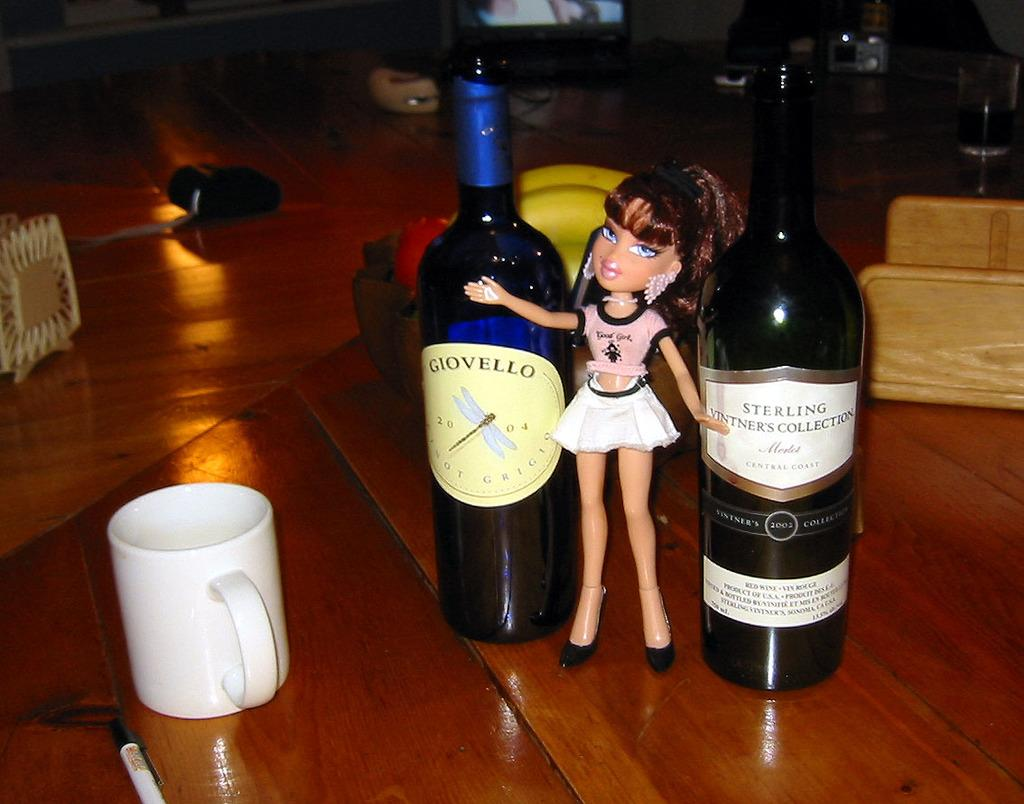What type of containers can be seen in the image? There are bottles and a cup in the image. What type of toy is present in the image? There is a toy doll in the image. What is the color of the surface on which the objects are placed? The surface is brown in color. Can you describe any other objects visible in the image? There are other objects on the brown color surface in the image. How does the net catch the string in the image? There is no net or string present in the image. 